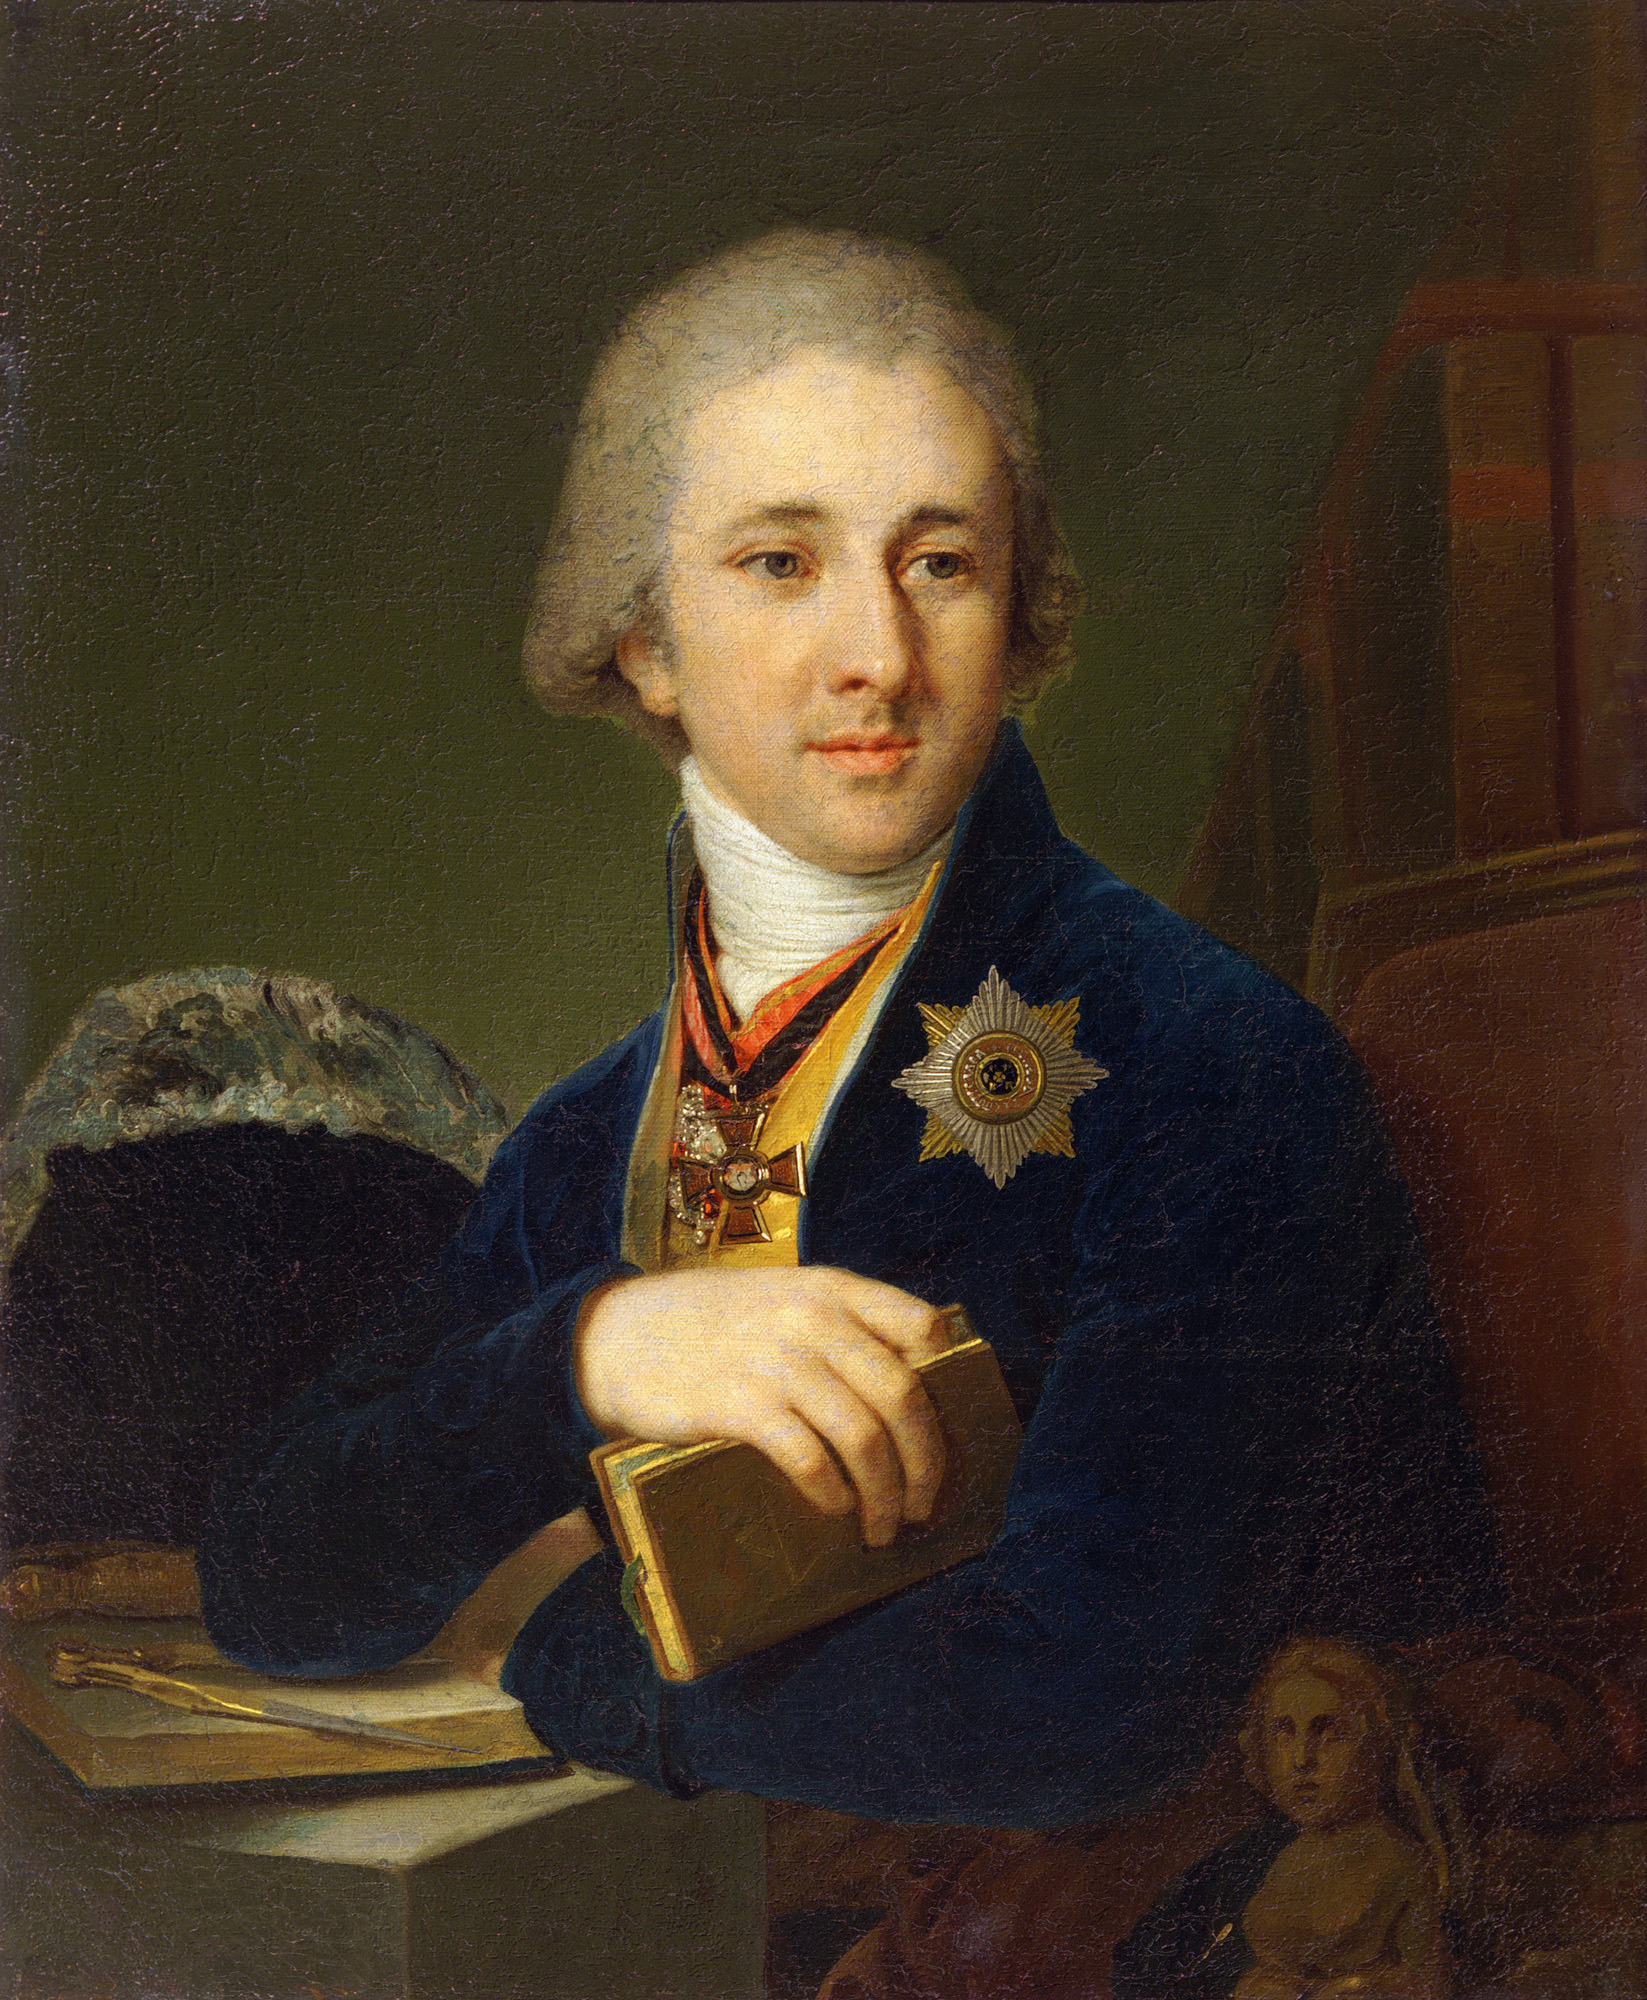What materials do you think were used to create this portrait? The portrait appears to have been painted using oil paints on canvas, a common and esteemed medium during the 18th century. The texture and depth of the colors indicate the use of high-quality pigments and skilled brushwork. The detailed rendering of fabrics and textures suggests meticulous layering and blending techniques often employed by master painters of that era. Can you describe the techniques used to achieve the realistic textures in the portrait? The artist likely employed techniques such as glazing and scumbling to achieve the realistic textures in the portrait. Glazing involves applying thin, semi-transparent layers of paint to build up depth and richness in color, while scumbling uses a dry brush to add soft, opaque layers for texture and highlights. The careful observation and rendering of light and shadow also contribute to the lifelike appearance of the fabric, skin, and other surfaces depicted. 